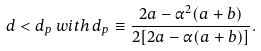Convert formula to latex. <formula><loc_0><loc_0><loc_500><loc_500>d < d _ { p } \, w i t h \, d _ { p } \equiv \frac { 2 a - \alpha ^ { 2 } ( a + b ) } { 2 [ 2 a - \alpha ( a + b ) ] } .</formula> 